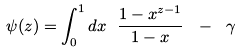Convert formula to latex. <formula><loc_0><loc_0><loc_500><loc_500>\psi ( z ) = \int _ { 0 } ^ { 1 } d x \ { \frac { 1 - x ^ { z - 1 } } { 1 - x } } \ - \ \gamma</formula> 